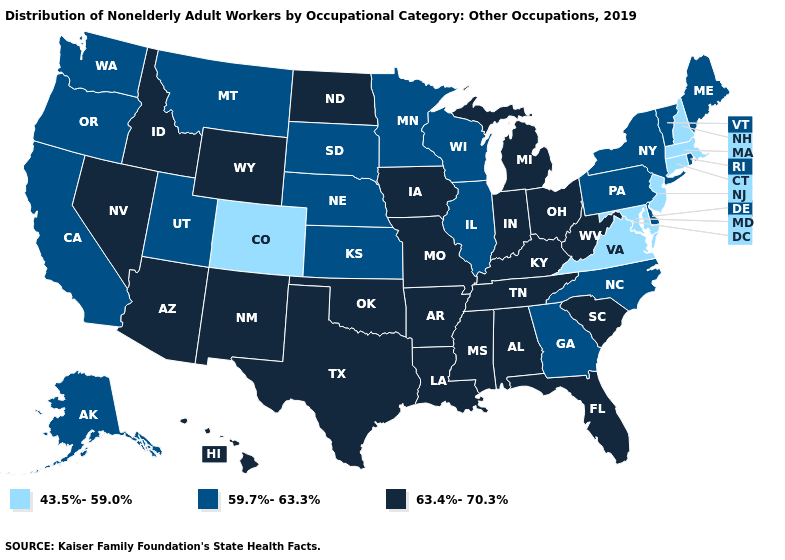Name the states that have a value in the range 59.7%-63.3%?
Give a very brief answer. Alaska, California, Delaware, Georgia, Illinois, Kansas, Maine, Minnesota, Montana, Nebraska, New York, North Carolina, Oregon, Pennsylvania, Rhode Island, South Dakota, Utah, Vermont, Washington, Wisconsin. Does Illinois have the highest value in the MidWest?
Answer briefly. No. What is the value of Connecticut?
Short answer required. 43.5%-59.0%. What is the lowest value in the West?
Short answer required. 43.5%-59.0%. Does Idaho have the lowest value in the West?
Short answer required. No. What is the highest value in states that border South Carolina?
Give a very brief answer. 59.7%-63.3%. What is the value of California?
Quick response, please. 59.7%-63.3%. What is the value of Massachusetts?
Give a very brief answer. 43.5%-59.0%. Does the first symbol in the legend represent the smallest category?
Short answer required. Yes. What is the highest value in the Northeast ?
Short answer required. 59.7%-63.3%. What is the value of Colorado?
Give a very brief answer. 43.5%-59.0%. Which states have the lowest value in the USA?
Be succinct. Colorado, Connecticut, Maryland, Massachusetts, New Hampshire, New Jersey, Virginia. Among the states that border South Carolina , which have the lowest value?
Short answer required. Georgia, North Carolina. What is the lowest value in states that border New York?
Short answer required. 43.5%-59.0%. Among the states that border New York , which have the lowest value?
Short answer required. Connecticut, Massachusetts, New Jersey. 